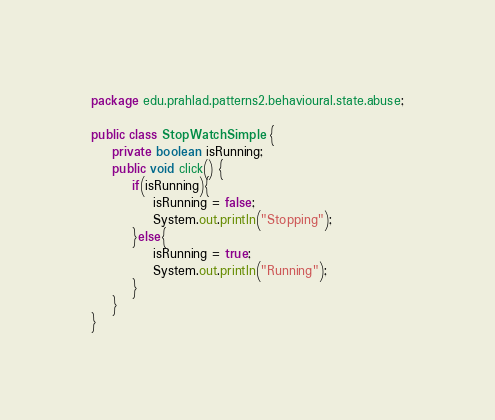Convert code to text. <code><loc_0><loc_0><loc_500><loc_500><_Java_>package edu.prahlad.patterns2.behavioural.state.abuse;

public class StopWatchSimple {
    private boolean isRunning;
    public void click() {
        if(isRunning){
            isRunning = false;
            System.out.println("Stopping");
        }else{
            isRunning = true;
            System.out.println("Running");
        }
    }
}
</code> 